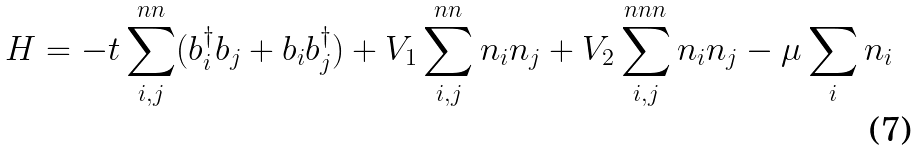Convert formula to latex. <formula><loc_0><loc_0><loc_500><loc_500>H = - t \sum _ { i , j } ^ { n n } ( b ^ { \dagger } _ { i } b _ { j } + b _ { i } b ^ { \dagger } _ { j } ) + V _ { 1 } \sum _ { i , j } ^ { n n } n _ { i } n _ { j } + V _ { 2 } \sum _ { i , j } ^ { n n n } n _ { i } n _ { j } - \mu \sum _ { i } n _ { i }</formula> 